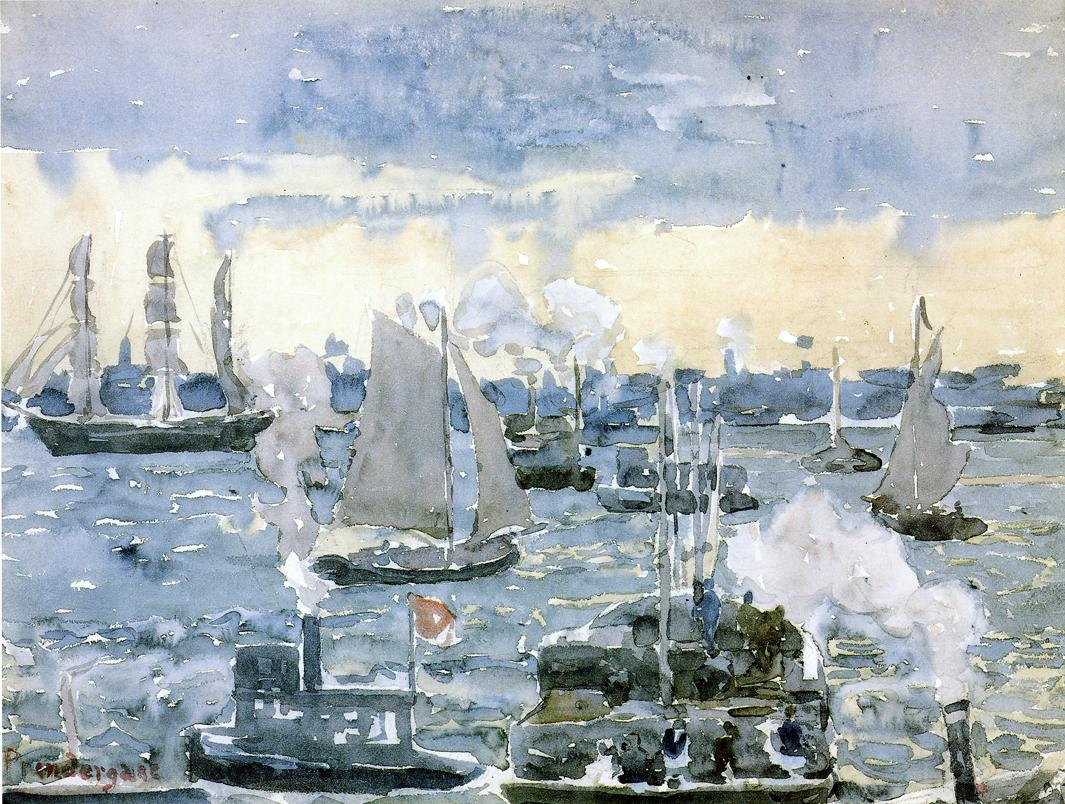What time of day do you think this scene takes place and why? This scene likely takes place during the late afternoon. The lighting in the painting suggests a time when the day is drawing to a close, casting a soft, diffused light across the harbor. The subtle hues of blue and gray in the sky, along with the gentle highlight on the water, indicate the sun's position low on the horizon, creating a tranquil and contemplative ambiance typical of late afternoon. What historical context can we deduce from this painting? From this painting, we can deduce that it was created during a time when both sailboats and steamships were in use, likely around the late 19th to early 20th century. The presence of steamships with smokestacks suggests the era of the Industrial Revolution, a period marked by significant advancements in technology and transportation. This mix of traditional sailing vessels and modern steam-powered ships indicates a transitional period in maritime history, where industrialization began to profoundly impact daily life and commerce. The loose, impressionist style aligns with artistic movements of that time, which focused on capturing the essence and fleeting moments of modern life. If this painting could tell a story, what would it be? If this painting could tell a story, it would narrate the tale of a thriving harbor community on the brink of transformation. It speaks of the coexistence of old and new—the traditional sailboats that rely on the capricious winds and the robust steamships that herald a new era of industrial progress. The choppy waters and bustling activity depict the everyday lives of sailors, merchants, and townsfolk, all contributing to the ebb and flow of commerce and industry. This is a story of endurance and adaptation, where the harbor stands as a testament to resilience amidst changing tides and technologies, capturing a moment in time when the world was moving swiftly towards modernity. 